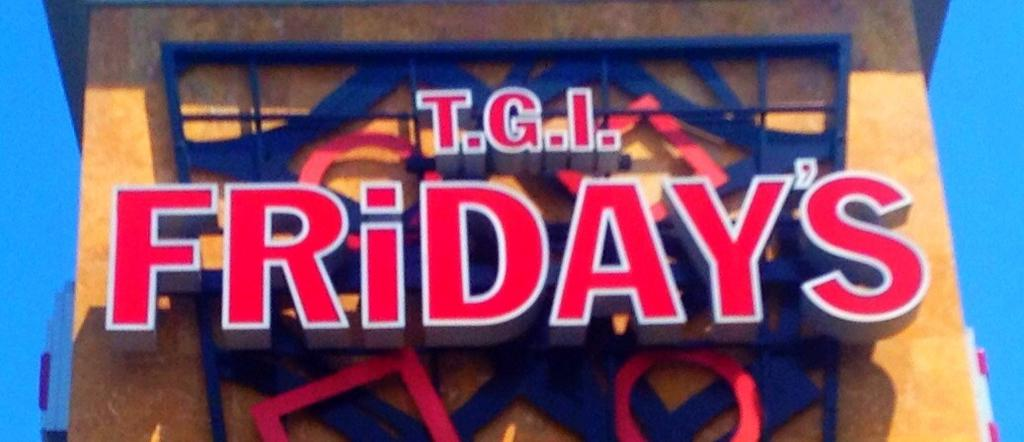What is the main structure in the image? There is a building in the image. What can be seen on the building's wall? The building has text on its wall. What is visible in the background of the image? The sky is visible in the background of the image. What type of spark can be seen coming from the building in the image? There is no spark present in the image; it only shows a building with text on its wall and the sky in the background. 